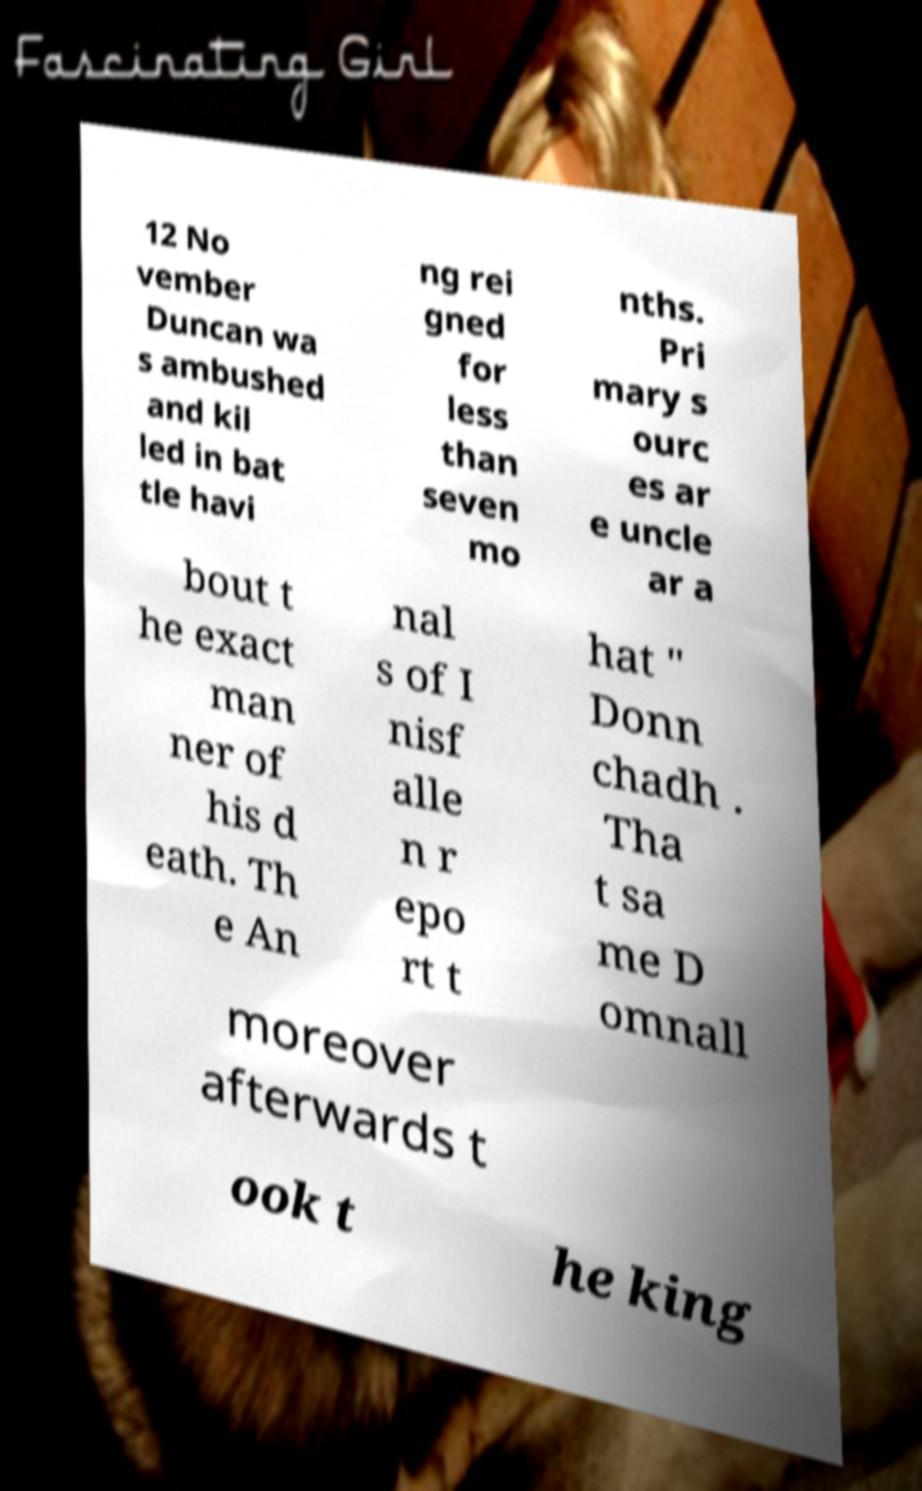Can you read and provide the text displayed in the image?This photo seems to have some interesting text. Can you extract and type it out for me? 12 No vember Duncan wa s ambushed and kil led in bat tle havi ng rei gned for less than seven mo nths. Pri mary s ourc es ar e uncle ar a bout t he exact man ner of his d eath. Th e An nal s of I nisf alle n r epo rt t hat " Donn chadh . Tha t sa me D omnall moreover afterwards t ook t he king 